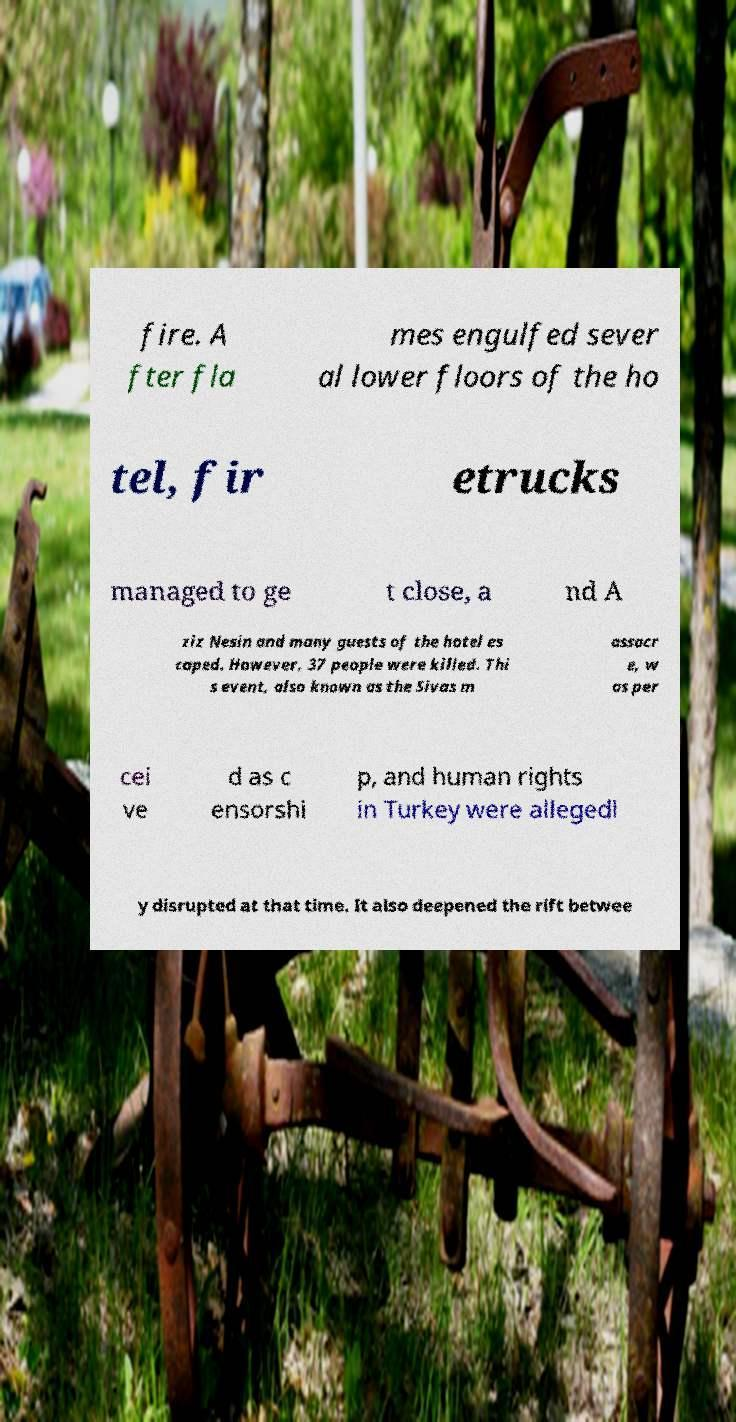I need the written content from this picture converted into text. Can you do that? fire. A fter fla mes engulfed sever al lower floors of the ho tel, fir etrucks managed to ge t close, a nd A ziz Nesin and many guests of the hotel es caped. However, 37 people were killed. Thi s event, also known as the Sivas m assacr e, w as per cei ve d as c ensorshi p, and human rights in Turkey were allegedl y disrupted at that time. It also deepened the rift betwee 